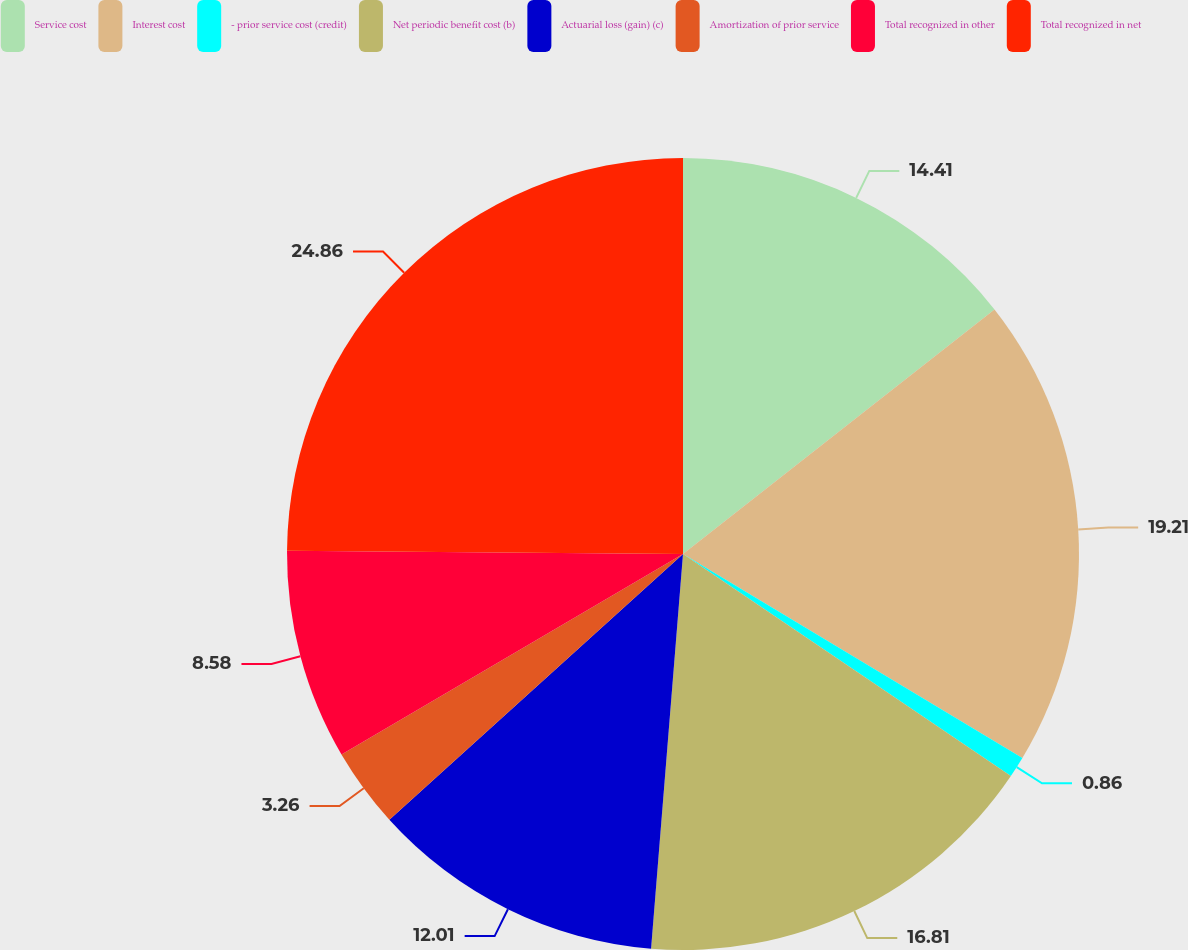Convert chart. <chart><loc_0><loc_0><loc_500><loc_500><pie_chart><fcel>Service cost<fcel>Interest cost<fcel>- prior service cost (credit)<fcel>Net periodic benefit cost (b)<fcel>Actuarial loss (gain) (c)<fcel>Amortization of prior service<fcel>Total recognized in other<fcel>Total recognized in net<nl><fcel>14.41%<fcel>19.21%<fcel>0.86%<fcel>16.81%<fcel>12.01%<fcel>3.26%<fcel>8.58%<fcel>24.87%<nl></chart> 